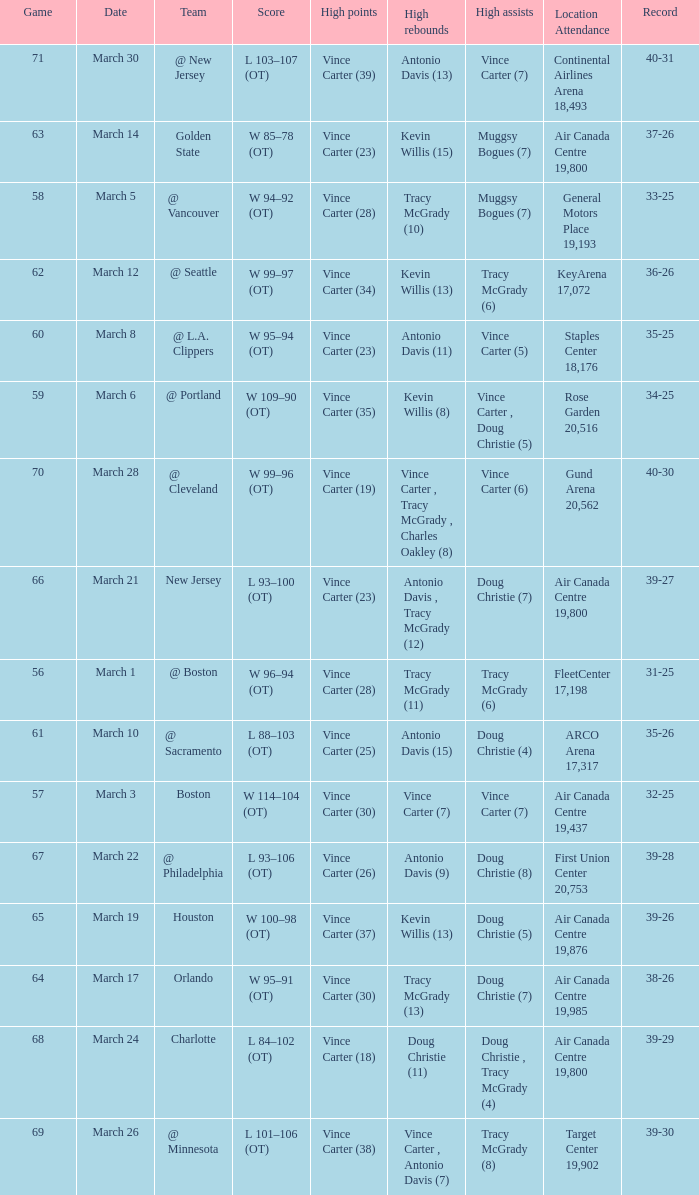What day was the attendance at the staples center 18,176? March 8. 